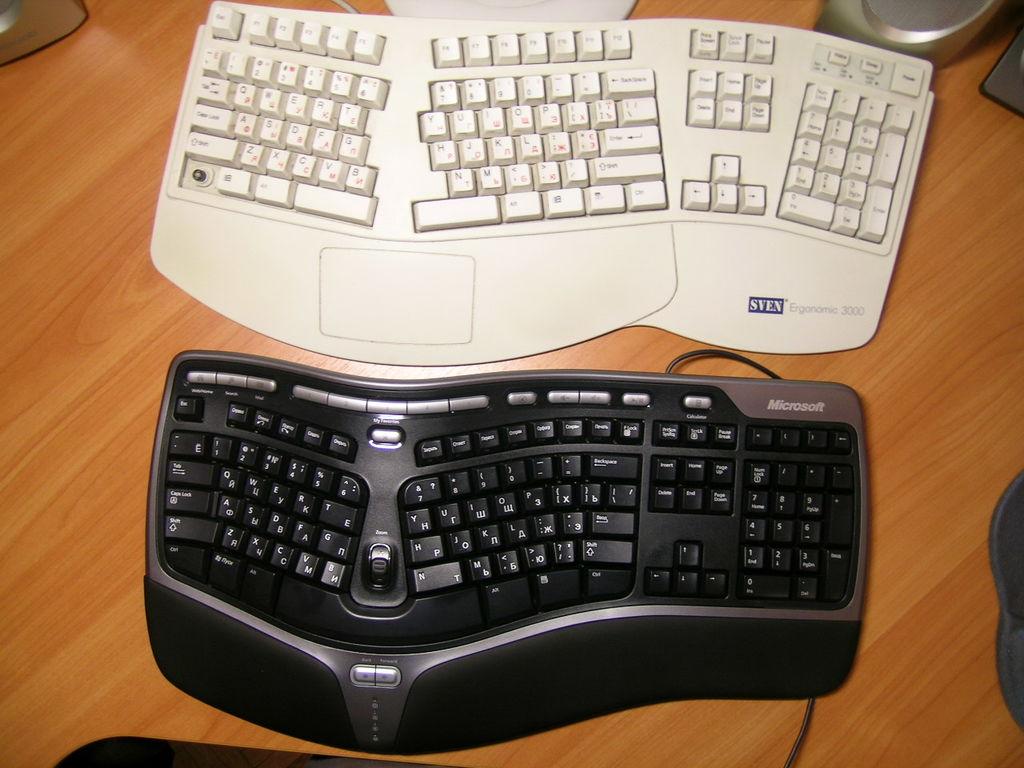What is the brand of the white leyboard?
Keep it short and to the point. Sven. 